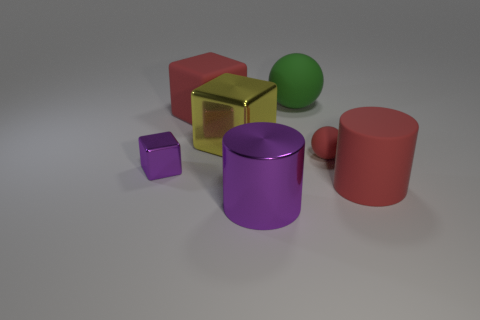What material is the small cube that is the same color as the metallic cylinder?
Make the answer very short. Metal. Do the large rubber cube and the tiny matte object have the same color?
Provide a short and direct response. Yes. There is a large yellow thing that is the same shape as the tiny purple metal thing; what material is it?
Keep it short and to the point. Metal. There is a cylinder behind the large purple cylinder; does it have the same color as the cube behind the big metallic cube?
Offer a very short reply. Yes. There is a big metal thing that is behind the red cylinder; what shape is it?
Give a very brief answer. Cube. What is the color of the metal cylinder?
Provide a short and direct response. Purple. What shape is the small red object that is the same material as the large red block?
Provide a short and direct response. Sphere. Do the cylinder that is in front of the red cylinder and the small purple shiny block have the same size?
Ensure brevity in your answer.  No. How many objects are large objects that are behind the red matte cube or big matte objects that are in front of the big green object?
Give a very brief answer. 3. There is a cylinder that is to the left of the red cylinder; does it have the same color as the small block?
Provide a succinct answer. Yes. 